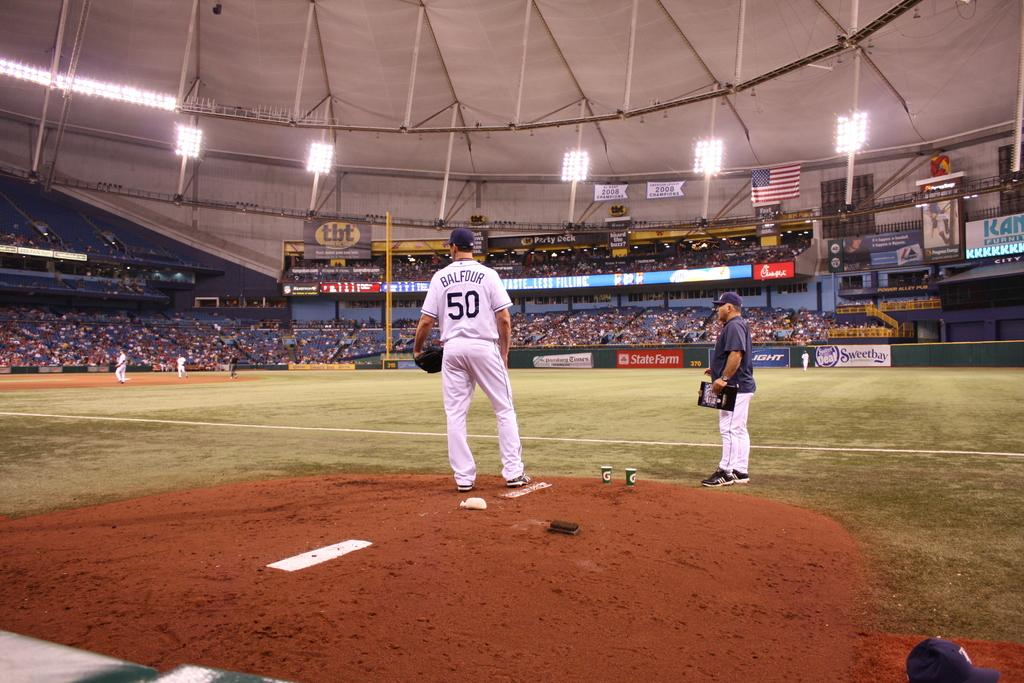<image>
Provide a brief description of the given image. A sportsman with the number 50 on a white shirt. 